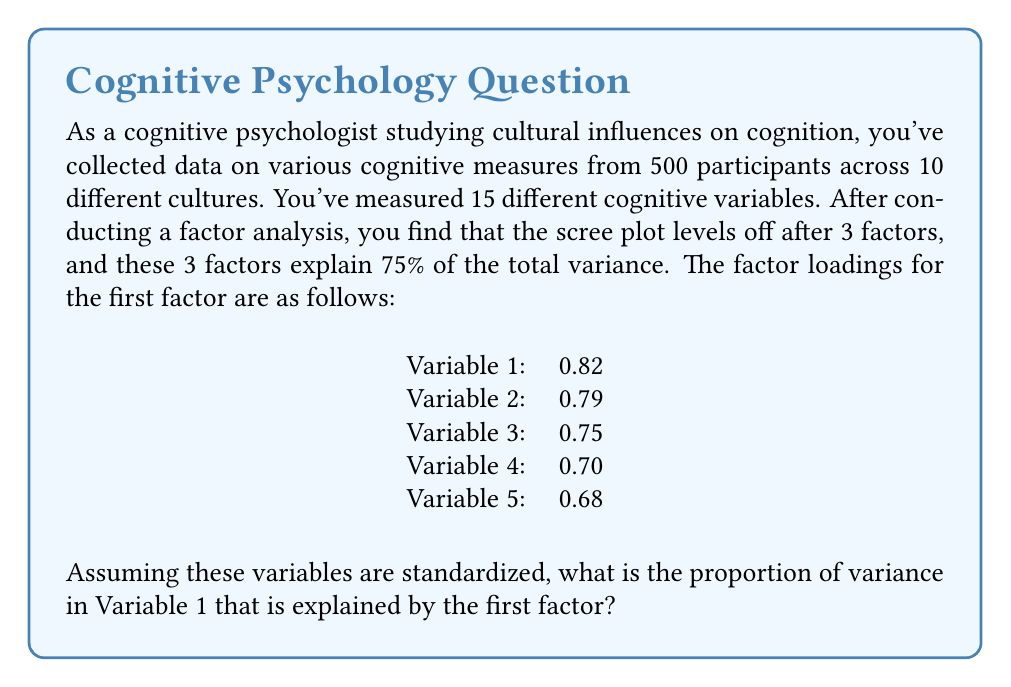Can you answer this question? To solve this problem, we need to understand the concept of factor loadings and communality in factor analysis.

1. Factor loadings represent the correlation between a variable and a factor. They range from -1 to 1.

2. The squared factor loading represents the proportion of variance in that variable explained by the factor.

3. For standardized variables, the total variance of each variable is 1.

4. The communality of a variable is the proportion of its variance that is explained by all the factors together. It's calculated as the sum of squared factor loadings across all factors for that variable.

5. In this case, we're only given the factor loading for the first factor, so we'll calculate the proportion of variance explained by just this factor.

6. The formula for the proportion of variance explained is:

   $$ \text{Proportion of Variance Explained} = (\text{Factor Loading})^2 $$

7. For Variable 1, the factor loading is 0.82.

8. Therefore, the proportion of variance explained is:

   $$ (0.82)^2 = 0.6724 $$

This means that 67.24% of the variance in Variable 1 is explained by the first factor.
Answer: 0.6724 or 67.24% 